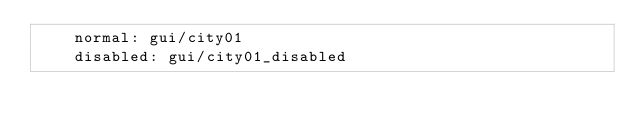Convert code to text. <code><loc_0><loc_0><loc_500><loc_500><_YAML_>    normal: gui/city01
    disabled: gui/city01_disabled
</code> 